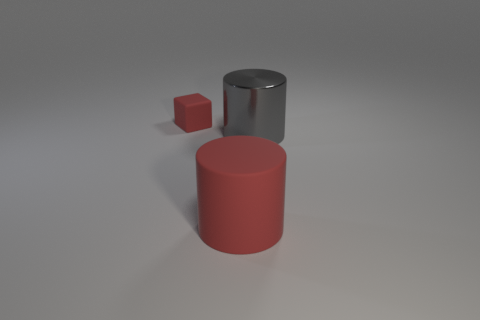Subtract all blue cubes. Subtract all brown cylinders. How many cubes are left? 1 Add 2 small red matte objects. How many objects exist? 5 Subtract all cubes. How many objects are left? 2 Subtract all matte cubes. Subtract all small things. How many objects are left? 1 Add 3 red matte cylinders. How many red matte cylinders are left? 4 Add 2 large yellow cylinders. How many large yellow cylinders exist? 2 Subtract 0 purple blocks. How many objects are left? 3 